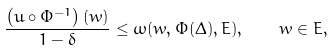<formula> <loc_0><loc_0><loc_500><loc_500>\frac { \left ( u \circ \Phi ^ { - 1 } \right ) ( w ) } { 1 - \delta } \leq \omega ( w , \Phi ( \Delta ) , E ) , \quad w \in E ,</formula> 